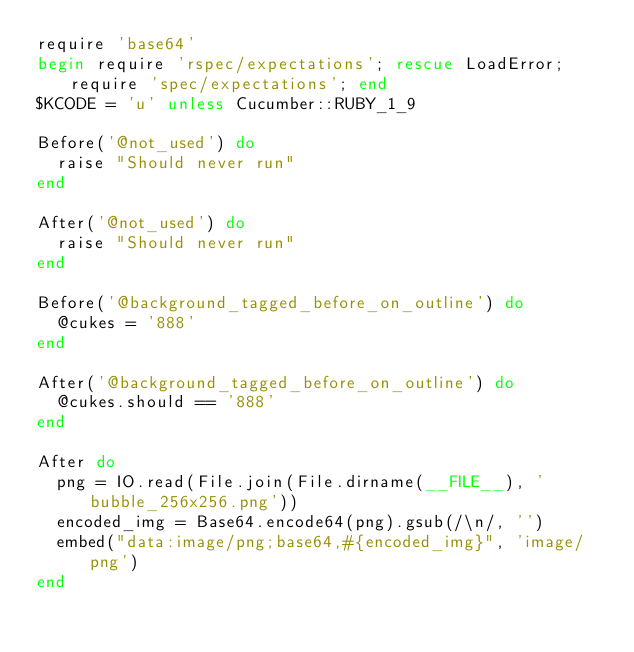Convert code to text. <code><loc_0><loc_0><loc_500><loc_500><_Ruby_>require 'base64'
begin require 'rspec/expectations'; rescue LoadError; require 'spec/expectations'; end
$KCODE = 'u' unless Cucumber::RUBY_1_9

Before('@not_used') do
  raise "Should never run"
end

After('@not_used') do
  raise "Should never run"
end

Before('@background_tagged_before_on_outline') do
  @cukes = '888'
end

After('@background_tagged_before_on_outline') do
  @cukes.should == '888'
end

After do
  png = IO.read(File.join(File.dirname(__FILE__), 'bubble_256x256.png'))
  encoded_img = Base64.encode64(png).gsub(/\n/, '')
  embed("data:image/png;base64,#{encoded_img}", 'image/png')
end

</code> 